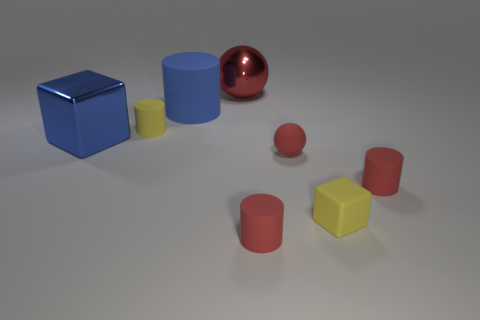Add 1 red metal spheres. How many objects exist? 9 Subtract all blue cylinders. How many cylinders are left? 3 Subtract all tiny matte cylinders. How many cylinders are left? 1 Subtract 0 purple spheres. How many objects are left? 8 Subtract all spheres. How many objects are left? 6 Subtract 2 blocks. How many blocks are left? 0 Subtract all yellow blocks. Subtract all brown spheres. How many blocks are left? 1 Subtract all gray blocks. How many yellow cylinders are left? 1 Subtract all yellow metal cubes. Subtract all matte things. How many objects are left? 2 Add 1 tiny yellow matte blocks. How many tiny yellow matte blocks are left? 2 